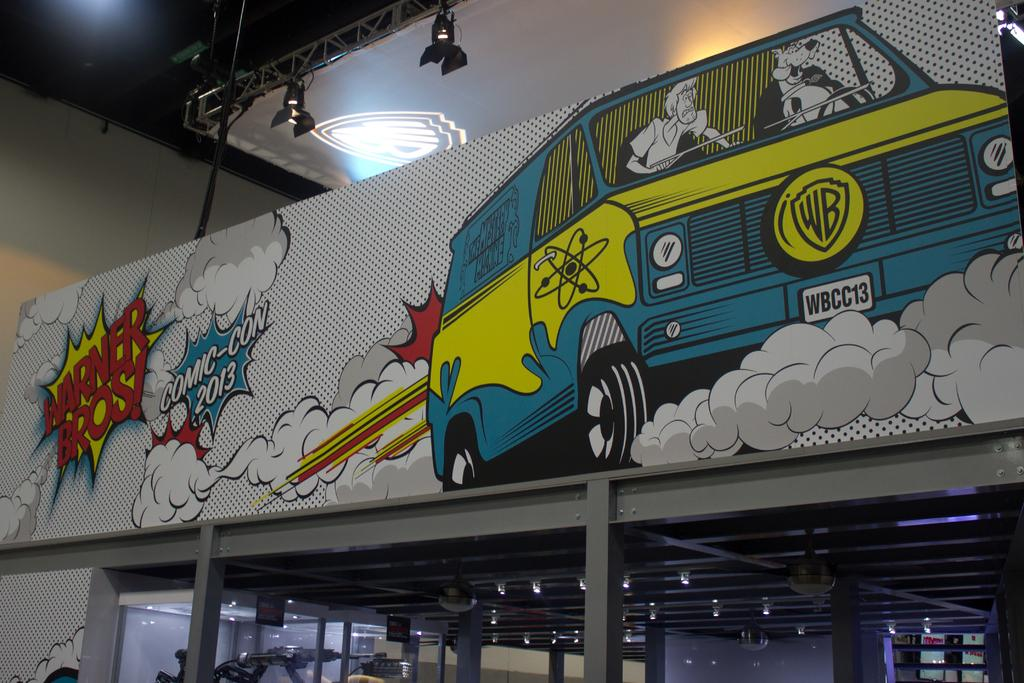What is the main structure visible in the image? There is a roof of a room in the image. What is featured on the roof of the room? There is a painting on the roof of the room. What type of hospital is depicted in the painting on the roof of the room? There is no hospital depicted in the painting on the roof of the room; it only features a painting. What kind of pie is shown in the image? There is no pie present in the image. 